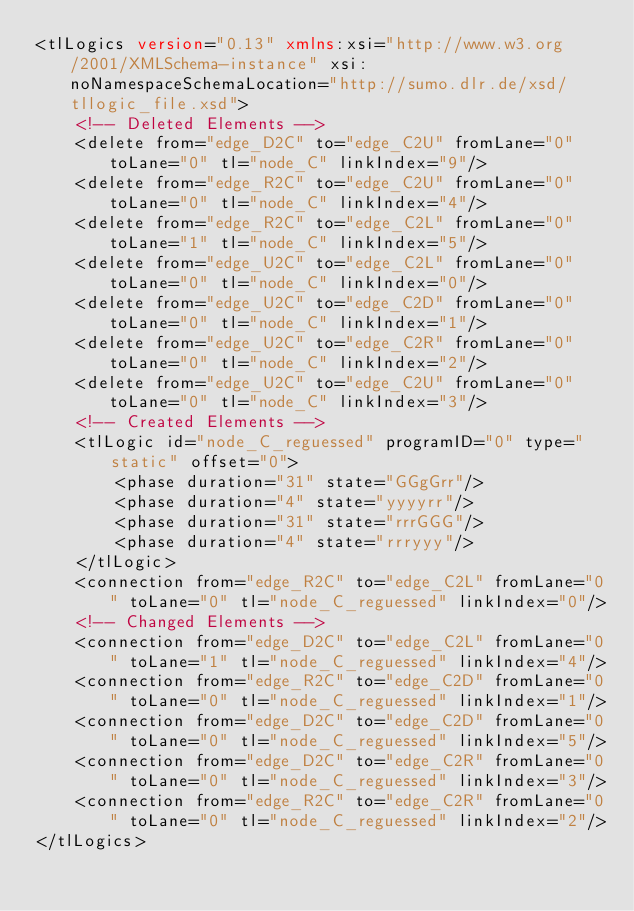Convert code to text. <code><loc_0><loc_0><loc_500><loc_500><_XML_><tlLogics version="0.13" xmlns:xsi="http://www.w3.org/2001/XMLSchema-instance" xsi:noNamespaceSchemaLocation="http://sumo.dlr.de/xsd/tllogic_file.xsd">
    <!-- Deleted Elements -->
    <delete from="edge_D2C" to="edge_C2U" fromLane="0" toLane="0" tl="node_C" linkIndex="9"/>
    <delete from="edge_R2C" to="edge_C2U" fromLane="0" toLane="0" tl="node_C" linkIndex="4"/>
    <delete from="edge_R2C" to="edge_C2L" fromLane="0" toLane="1" tl="node_C" linkIndex="5"/>
    <delete from="edge_U2C" to="edge_C2L" fromLane="0" toLane="0" tl="node_C" linkIndex="0"/>
    <delete from="edge_U2C" to="edge_C2D" fromLane="0" toLane="0" tl="node_C" linkIndex="1"/>
    <delete from="edge_U2C" to="edge_C2R" fromLane="0" toLane="0" tl="node_C" linkIndex="2"/>
    <delete from="edge_U2C" to="edge_C2U" fromLane="0" toLane="0" tl="node_C" linkIndex="3"/>
    <!-- Created Elements -->
    <tlLogic id="node_C_reguessed" programID="0" type="static" offset="0">
        <phase duration="31" state="GGgGrr"/>
        <phase duration="4" state="yyyyrr"/>
        <phase duration="31" state="rrrGGG"/>
        <phase duration="4" state="rrryyy"/>
    </tlLogic>
    <connection from="edge_R2C" to="edge_C2L" fromLane="0" toLane="0" tl="node_C_reguessed" linkIndex="0"/>
    <!-- Changed Elements -->
    <connection from="edge_D2C" to="edge_C2L" fromLane="0" toLane="1" tl="node_C_reguessed" linkIndex="4"/>
    <connection from="edge_R2C" to="edge_C2D" fromLane="0" toLane="0" tl="node_C_reguessed" linkIndex="1"/>
    <connection from="edge_D2C" to="edge_C2D" fromLane="0" toLane="0" tl="node_C_reguessed" linkIndex="5"/>
    <connection from="edge_D2C" to="edge_C2R" fromLane="0" toLane="0" tl="node_C_reguessed" linkIndex="3"/>
    <connection from="edge_R2C" to="edge_C2R" fromLane="0" toLane="0" tl="node_C_reguessed" linkIndex="2"/>
</tlLogics>
</code> 